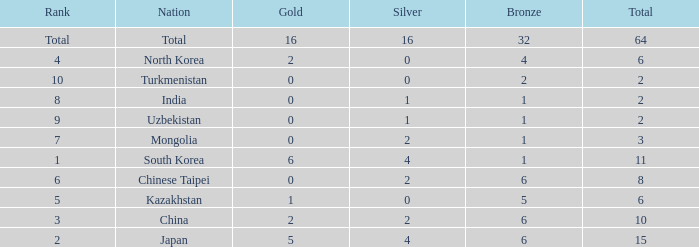What rank is Turkmenistan, who had 0 silver's and Less than 2 golds? 10.0. 